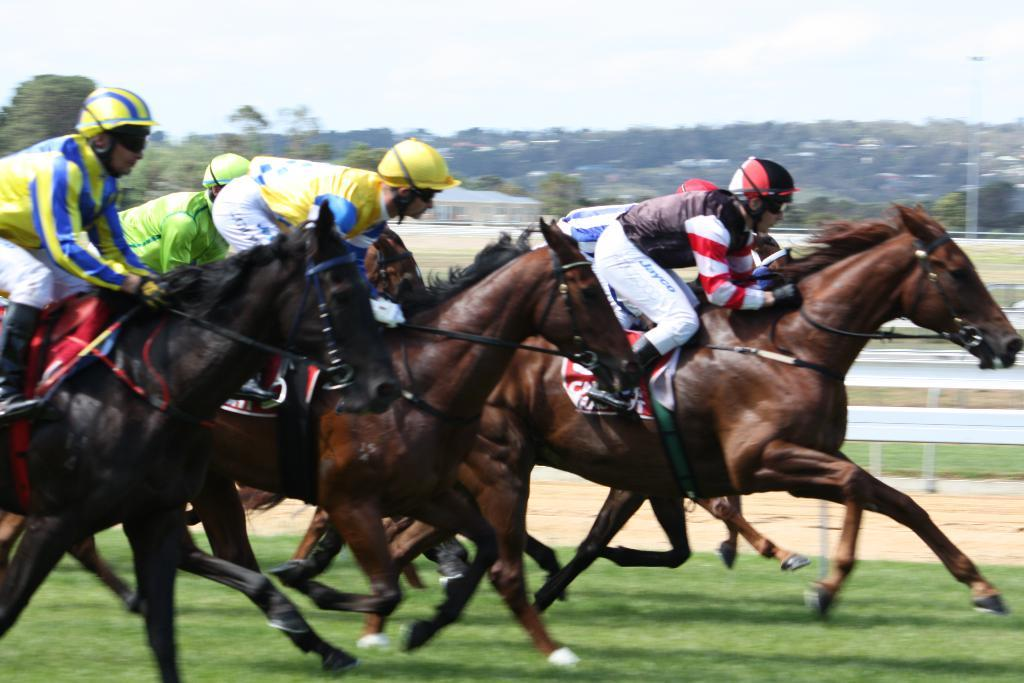Who or what can be seen in the image? There are people in the image. What are the people wearing on their heads? The people are wearing helmets. What are the people doing in the image? The people are riding horses. What type of barrier is present in the image? There is fencing in the image. What type of natural elements can be seen in the image? There are trees and plants in the image. What type of man-made structures can be seen in the image? There are poles and buildings in the image. What type of board is being used for religious purposes in the image? There is no board present in the image, and no religious practices are depicted. Is there a volcano visible in the image? No, there is no volcano present in the image. 